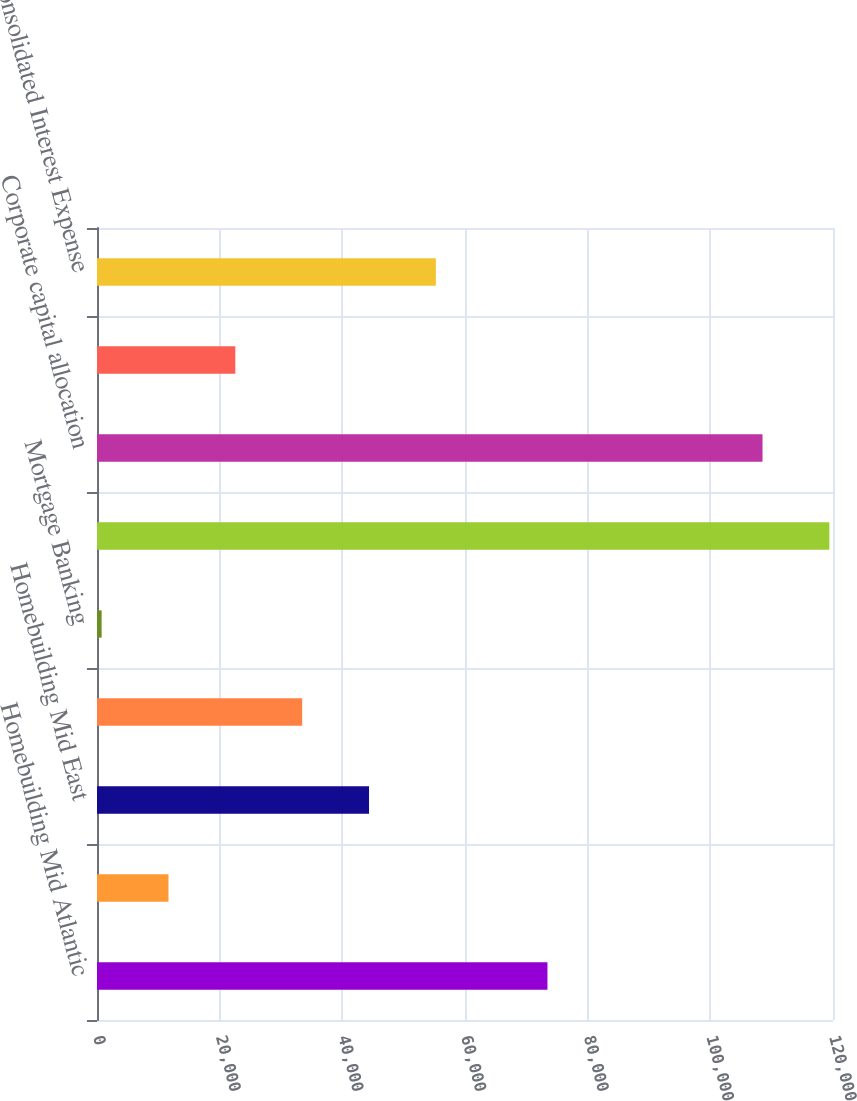<chart> <loc_0><loc_0><loc_500><loc_500><bar_chart><fcel>Homebuilding Mid Atlantic<fcel>Homebuilding North East<fcel>Homebuilding Mid East<fcel>Homebuilding South East<fcel>Mortgage Banking<fcel>Total Segment Interest Expense<fcel>Corporate capital allocation<fcel>Senior note and other interest<fcel>Consolidated Interest Expense<nl><fcel>73441<fcel>11653.4<fcel>44351.6<fcel>33452.2<fcel>754<fcel>119408<fcel>108509<fcel>22552.8<fcel>55251<nl></chart> 